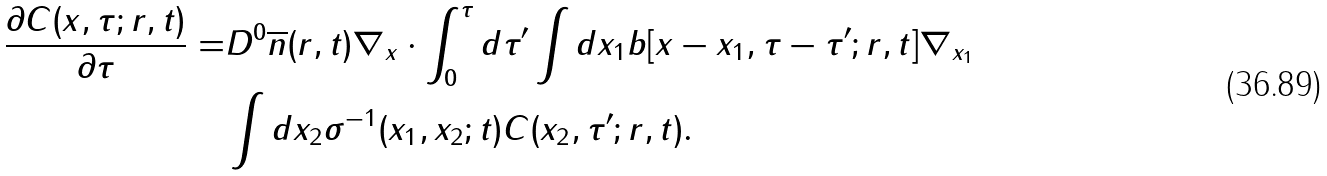Convert formula to latex. <formula><loc_0><loc_0><loc_500><loc_500>\frac { \partial C ( x , \tau ; r , t ) } { \partial \tau } = & D ^ { 0 } \overline { n } ( r , t ) { \nabla } _ { x } \cdot \int _ { 0 } ^ { \tau } d \tau ^ { \prime } \int d x _ { 1 } b [ x - x _ { 1 } , \tau - \tau ^ { \prime } ; r , t ] \nabla _ { x _ { 1 } } \\ & \int d x _ { 2 } \sigma ^ { - 1 } ( x _ { 1 } , x _ { 2 } ; t ) C ( x _ { 2 } , \tau ^ { \prime } ; r , t ) .</formula> 